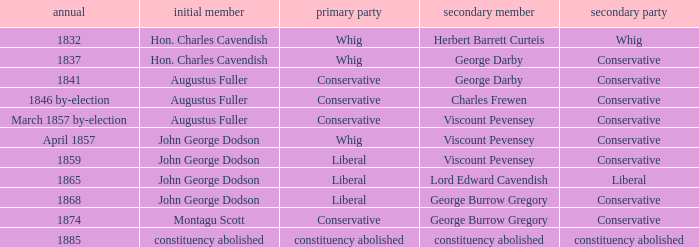In 1837, who was the 2nd member who's 2nd party was conservative. George Darby. 